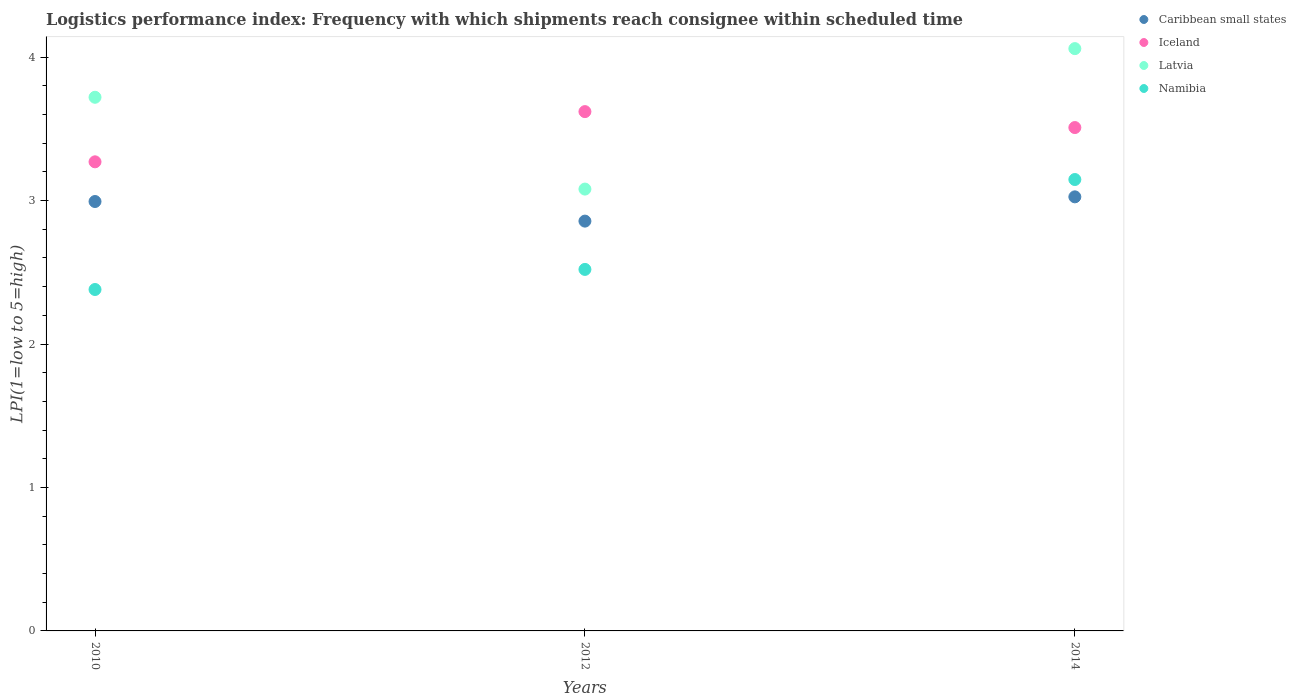How many different coloured dotlines are there?
Your answer should be compact. 4. What is the logistics performance index in Caribbean small states in 2014?
Give a very brief answer. 3.03. Across all years, what is the maximum logistics performance index in Namibia?
Make the answer very short. 3.15. Across all years, what is the minimum logistics performance index in Latvia?
Make the answer very short. 3.08. In which year was the logistics performance index in Latvia minimum?
Make the answer very short. 2012. What is the total logistics performance index in Latvia in the graph?
Keep it short and to the point. 10.86. What is the difference between the logistics performance index in Namibia in 2012 and that in 2014?
Offer a terse response. -0.63. What is the difference between the logistics performance index in Latvia in 2014 and the logistics performance index in Iceland in 2012?
Keep it short and to the point. 0.44. What is the average logistics performance index in Latvia per year?
Provide a short and direct response. 3.62. In the year 2014, what is the difference between the logistics performance index in Latvia and logistics performance index in Caribbean small states?
Offer a very short reply. 1.03. In how many years, is the logistics performance index in Caribbean small states greater than 3.6?
Give a very brief answer. 0. What is the ratio of the logistics performance index in Namibia in 2012 to that in 2014?
Provide a succinct answer. 0.8. Is the logistics performance index in Iceland in 2010 less than that in 2012?
Give a very brief answer. Yes. Is the difference between the logistics performance index in Latvia in 2010 and 2014 greater than the difference between the logistics performance index in Caribbean small states in 2010 and 2014?
Offer a terse response. No. What is the difference between the highest and the second highest logistics performance index in Caribbean small states?
Keep it short and to the point. 0.03. What is the difference between the highest and the lowest logistics performance index in Latvia?
Keep it short and to the point. 0.98. Is it the case that in every year, the sum of the logistics performance index in Iceland and logistics performance index in Caribbean small states  is greater than the sum of logistics performance index in Latvia and logistics performance index in Namibia?
Ensure brevity in your answer.  Yes. Is the logistics performance index in Iceland strictly greater than the logistics performance index in Namibia over the years?
Your answer should be very brief. Yes. How many dotlines are there?
Ensure brevity in your answer.  4. What is the difference between two consecutive major ticks on the Y-axis?
Ensure brevity in your answer.  1. How many legend labels are there?
Provide a short and direct response. 4. What is the title of the graph?
Your answer should be very brief. Logistics performance index: Frequency with which shipments reach consignee within scheduled time. Does "Kyrgyz Republic" appear as one of the legend labels in the graph?
Your response must be concise. No. What is the label or title of the Y-axis?
Keep it short and to the point. LPI(1=low to 5=high). What is the LPI(1=low to 5=high) in Caribbean small states in 2010?
Offer a terse response. 2.99. What is the LPI(1=low to 5=high) of Iceland in 2010?
Offer a terse response. 3.27. What is the LPI(1=low to 5=high) of Latvia in 2010?
Your answer should be very brief. 3.72. What is the LPI(1=low to 5=high) in Namibia in 2010?
Your answer should be very brief. 2.38. What is the LPI(1=low to 5=high) of Caribbean small states in 2012?
Ensure brevity in your answer.  2.86. What is the LPI(1=low to 5=high) of Iceland in 2012?
Offer a very short reply. 3.62. What is the LPI(1=low to 5=high) of Latvia in 2012?
Your response must be concise. 3.08. What is the LPI(1=low to 5=high) of Namibia in 2012?
Your answer should be compact. 2.52. What is the LPI(1=low to 5=high) in Caribbean small states in 2014?
Keep it short and to the point. 3.03. What is the LPI(1=low to 5=high) in Iceland in 2014?
Keep it short and to the point. 3.51. What is the LPI(1=low to 5=high) in Latvia in 2014?
Your answer should be compact. 4.06. What is the LPI(1=low to 5=high) of Namibia in 2014?
Offer a terse response. 3.15. Across all years, what is the maximum LPI(1=low to 5=high) in Caribbean small states?
Keep it short and to the point. 3.03. Across all years, what is the maximum LPI(1=low to 5=high) in Iceland?
Give a very brief answer. 3.62. Across all years, what is the maximum LPI(1=low to 5=high) of Latvia?
Your response must be concise. 4.06. Across all years, what is the maximum LPI(1=low to 5=high) of Namibia?
Your response must be concise. 3.15. Across all years, what is the minimum LPI(1=low to 5=high) of Caribbean small states?
Your answer should be compact. 2.86. Across all years, what is the minimum LPI(1=low to 5=high) in Iceland?
Keep it short and to the point. 3.27. Across all years, what is the minimum LPI(1=low to 5=high) of Latvia?
Your answer should be very brief. 3.08. Across all years, what is the minimum LPI(1=low to 5=high) in Namibia?
Your answer should be very brief. 2.38. What is the total LPI(1=low to 5=high) of Caribbean small states in the graph?
Offer a terse response. 8.88. What is the total LPI(1=low to 5=high) in Iceland in the graph?
Give a very brief answer. 10.4. What is the total LPI(1=low to 5=high) of Latvia in the graph?
Provide a succinct answer. 10.86. What is the total LPI(1=low to 5=high) of Namibia in the graph?
Ensure brevity in your answer.  8.05. What is the difference between the LPI(1=low to 5=high) in Caribbean small states in 2010 and that in 2012?
Ensure brevity in your answer.  0.14. What is the difference between the LPI(1=low to 5=high) of Iceland in 2010 and that in 2012?
Give a very brief answer. -0.35. What is the difference between the LPI(1=low to 5=high) of Latvia in 2010 and that in 2012?
Give a very brief answer. 0.64. What is the difference between the LPI(1=low to 5=high) of Namibia in 2010 and that in 2012?
Offer a very short reply. -0.14. What is the difference between the LPI(1=low to 5=high) in Caribbean small states in 2010 and that in 2014?
Your answer should be compact. -0.03. What is the difference between the LPI(1=low to 5=high) of Iceland in 2010 and that in 2014?
Give a very brief answer. -0.24. What is the difference between the LPI(1=low to 5=high) of Latvia in 2010 and that in 2014?
Your answer should be compact. -0.34. What is the difference between the LPI(1=low to 5=high) of Namibia in 2010 and that in 2014?
Your response must be concise. -0.77. What is the difference between the LPI(1=low to 5=high) of Caribbean small states in 2012 and that in 2014?
Give a very brief answer. -0.17. What is the difference between the LPI(1=low to 5=high) of Iceland in 2012 and that in 2014?
Your answer should be very brief. 0.11. What is the difference between the LPI(1=low to 5=high) of Latvia in 2012 and that in 2014?
Give a very brief answer. -0.98. What is the difference between the LPI(1=low to 5=high) of Namibia in 2012 and that in 2014?
Make the answer very short. -0.63. What is the difference between the LPI(1=low to 5=high) in Caribbean small states in 2010 and the LPI(1=low to 5=high) in Iceland in 2012?
Ensure brevity in your answer.  -0.63. What is the difference between the LPI(1=low to 5=high) of Caribbean small states in 2010 and the LPI(1=low to 5=high) of Latvia in 2012?
Offer a very short reply. -0.09. What is the difference between the LPI(1=low to 5=high) of Caribbean small states in 2010 and the LPI(1=low to 5=high) of Namibia in 2012?
Give a very brief answer. 0.47. What is the difference between the LPI(1=low to 5=high) of Iceland in 2010 and the LPI(1=low to 5=high) of Latvia in 2012?
Provide a succinct answer. 0.19. What is the difference between the LPI(1=low to 5=high) in Latvia in 2010 and the LPI(1=low to 5=high) in Namibia in 2012?
Provide a succinct answer. 1.2. What is the difference between the LPI(1=low to 5=high) of Caribbean small states in 2010 and the LPI(1=low to 5=high) of Iceland in 2014?
Provide a short and direct response. -0.52. What is the difference between the LPI(1=low to 5=high) in Caribbean small states in 2010 and the LPI(1=low to 5=high) in Latvia in 2014?
Your answer should be very brief. -1.07. What is the difference between the LPI(1=low to 5=high) in Caribbean small states in 2010 and the LPI(1=low to 5=high) in Namibia in 2014?
Give a very brief answer. -0.15. What is the difference between the LPI(1=low to 5=high) in Iceland in 2010 and the LPI(1=low to 5=high) in Latvia in 2014?
Your response must be concise. -0.79. What is the difference between the LPI(1=low to 5=high) in Iceland in 2010 and the LPI(1=low to 5=high) in Namibia in 2014?
Ensure brevity in your answer.  0.12. What is the difference between the LPI(1=low to 5=high) of Latvia in 2010 and the LPI(1=low to 5=high) of Namibia in 2014?
Provide a short and direct response. 0.57. What is the difference between the LPI(1=low to 5=high) of Caribbean small states in 2012 and the LPI(1=low to 5=high) of Iceland in 2014?
Your answer should be very brief. -0.65. What is the difference between the LPI(1=low to 5=high) of Caribbean small states in 2012 and the LPI(1=low to 5=high) of Latvia in 2014?
Provide a short and direct response. -1.2. What is the difference between the LPI(1=low to 5=high) of Caribbean small states in 2012 and the LPI(1=low to 5=high) of Namibia in 2014?
Provide a succinct answer. -0.29. What is the difference between the LPI(1=low to 5=high) in Iceland in 2012 and the LPI(1=low to 5=high) in Latvia in 2014?
Your response must be concise. -0.44. What is the difference between the LPI(1=low to 5=high) in Iceland in 2012 and the LPI(1=low to 5=high) in Namibia in 2014?
Your answer should be compact. 0.47. What is the difference between the LPI(1=low to 5=high) in Latvia in 2012 and the LPI(1=low to 5=high) in Namibia in 2014?
Ensure brevity in your answer.  -0.07. What is the average LPI(1=low to 5=high) of Caribbean small states per year?
Ensure brevity in your answer.  2.96. What is the average LPI(1=low to 5=high) of Iceland per year?
Keep it short and to the point. 3.47. What is the average LPI(1=low to 5=high) of Latvia per year?
Provide a short and direct response. 3.62. What is the average LPI(1=low to 5=high) in Namibia per year?
Your answer should be compact. 2.68. In the year 2010, what is the difference between the LPI(1=low to 5=high) in Caribbean small states and LPI(1=low to 5=high) in Iceland?
Offer a terse response. -0.28. In the year 2010, what is the difference between the LPI(1=low to 5=high) in Caribbean small states and LPI(1=low to 5=high) in Latvia?
Your answer should be compact. -0.73. In the year 2010, what is the difference between the LPI(1=low to 5=high) in Caribbean small states and LPI(1=low to 5=high) in Namibia?
Your answer should be very brief. 0.61. In the year 2010, what is the difference between the LPI(1=low to 5=high) in Iceland and LPI(1=low to 5=high) in Latvia?
Your answer should be compact. -0.45. In the year 2010, what is the difference between the LPI(1=low to 5=high) in Iceland and LPI(1=low to 5=high) in Namibia?
Provide a short and direct response. 0.89. In the year 2010, what is the difference between the LPI(1=low to 5=high) of Latvia and LPI(1=low to 5=high) of Namibia?
Offer a very short reply. 1.34. In the year 2012, what is the difference between the LPI(1=low to 5=high) in Caribbean small states and LPI(1=low to 5=high) in Iceland?
Your answer should be compact. -0.76. In the year 2012, what is the difference between the LPI(1=low to 5=high) in Caribbean small states and LPI(1=low to 5=high) in Latvia?
Provide a succinct answer. -0.22. In the year 2012, what is the difference between the LPI(1=low to 5=high) of Caribbean small states and LPI(1=low to 5=high) of Namibia?
Keep it short and to the point. 0.34. In the year 2012, what is the difference between the LPI(1=low to 5=high) of Iceland and LPI(1=low to 5=high) of Latvia?
Your response must be concise. 0.54. In the year 2012, what is the difference between the LPI(1=low to 5=high) in Latvia and LPI(1=low to 5=high) in Namibia?
Keep it short and to the point. 0.56. In the year 2014, what is the difference between the LPI(1=low to 5=high) in Caribbean small states and LPI(1=low to 5=high) in Iceland?
Your response must be concise. -0.48. In the year 2014, what is the difference between the LPI(1=low to 5=high) of Caribbean small states and LPI(1=low to 5=high) of Latvia?
Your answer should be very brief. -1.03. In the year 2014, what is the difference between the LPI(1=low to 5=high) in Caribbean small states and LPI(1=low to 5=high) in Namibia?
Give a very brief answer. -0.12. In the year 2014, what is the difference between the LPI(1=low to 5=high) in Iceland and LPI(1=low to 5=high) in Latvia?
Make the answer very short. -0.55. In the year 2014, what is the difference between the LPI(1=low to 5=high) in Iceland and LPI(1=low to 5=high) in Namibia?
Your response must be concise. 0.36. In the year 2014, what is the difference between the LPI(1=low to 5=high) of Latvia and LPI(1=low to 5=high) of Namibia?
Ensure brevity in your answer.  0.91. What is the ratio of the LPI(1=low to 5=high) of Caribbean small states in 2010 to that in 2012?
Offer a very short reply. 1.05. What is the ratio of the LPI(1=low to 5=high) in Iceland in 2010 to that in 2012?
Keep it short and to the point. 0.9. What is the ratio of the LPI(1=low to 5=high) in Latvia in 2010 to that in 2012?
Make the answer very short. 1.21. What is the ratio of the LPI(1=low to 5=high) of Iceland in 2010 to that in 2014?
Ensure brevity in your answer.  0.93. What is the ratio of the LPI(1=low to 5=high) of Latvia in 2010 to that in 2014?
Give a very brief answer. 0.92. What is the ratio of the LPI(1=low to 5=high) of Namibia in 2010 to that in 2014?
Ensure brevity in your answer.  0.76. What is the ratio of the LPI(1=low to 5=high) in Caribbean small states in 2012 to that in 2014?
Provide a succinct answer. 0.94. What is the ratio of the LPI(1=low to 5=high) in Iceland in 2012 to that in 2014?
Your answer should be very brief. 1.03. What is the ratio of the LPI(1=low to 5=high) in Latvia in 2012 to that in 2014?
Your answer should be very brief. 0.76. What is the ratio of the LPI(1=low to 5=high) in Namibia in 2012 to that in 2014?
Your answer should be compact. 0.8. What is the difference between the highest and the second highest LPI(1=low to 5=high) in Caribbean small states?
Keep it short and to the point. 0.03. What is the difference between the highest and the second highest LPI(1=low to 5=high) in Iceland?
Give a very brief answer. 0.11. What is the difference between the highest and the second highest LPI(1=low to 5=high) of Latvia?
Your answer should be compact. 0.34. What is the difference between the highest and the second highest LPI(1=low to 5=high) in Namibia?
Your response must be concise. 0.63. What is the difference between the highest and the lowest LPI(1=low to 5=high) in Caribbean small states?
Your answer should be very brief. 0.17. What is the difference between the highest and the lowest LPI(1=low to 5=high) of Latvia?
Your answer should be compact. 0.98. What is the difference between the highest and the lowest LPI(1=low to 5=high) in Namibia?
Your answer should be very brief. 0.77. 